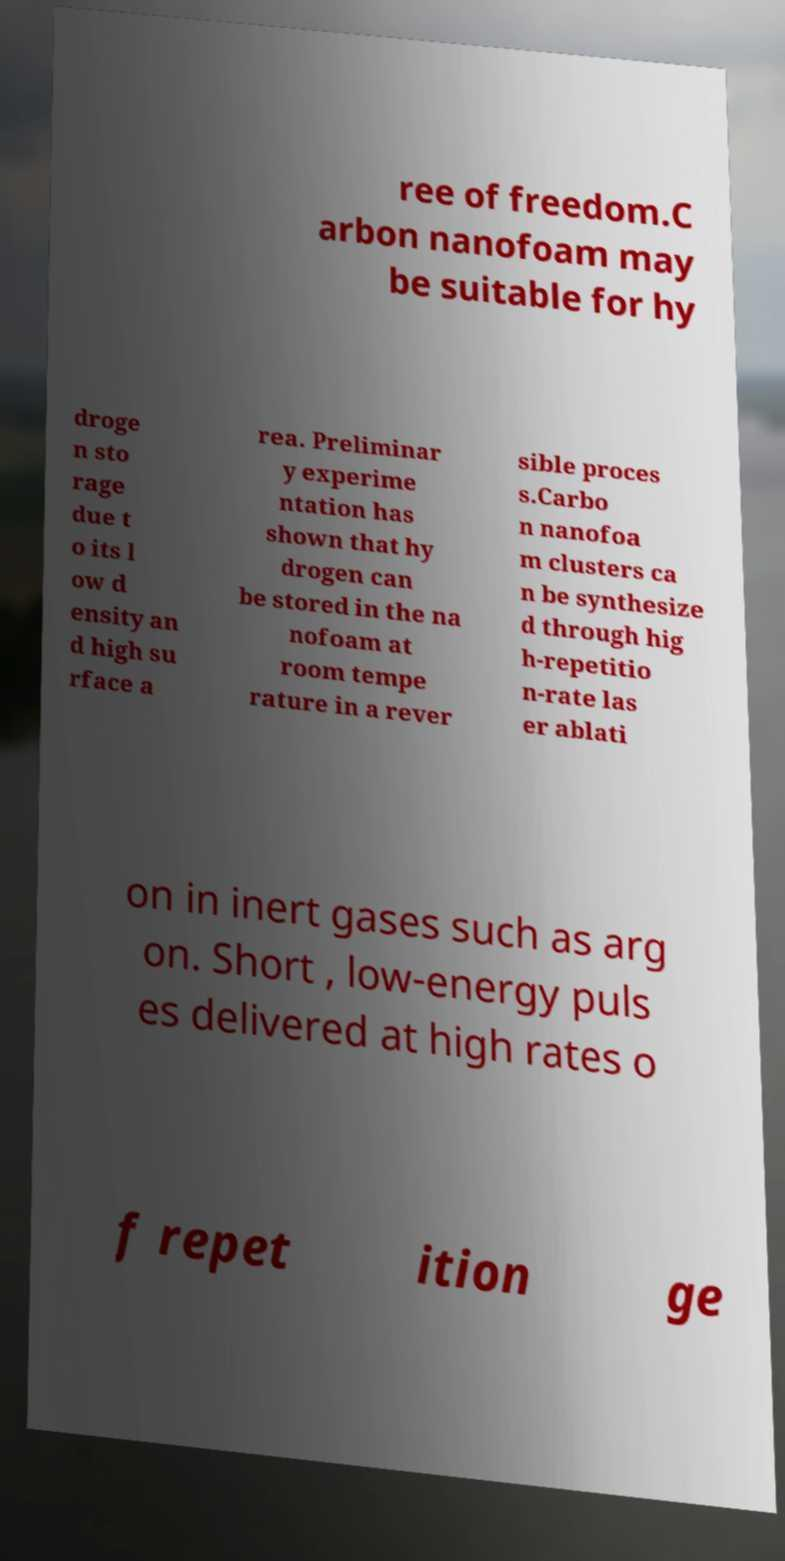Please read and relay the text visible in this image. What does it say? ree of freedom.C arbon nanofoam may be suitable for hy droge n sto rage due t o its l ow d ensity an d high su rface a rea. Preliminar y experime ntation has shown that hy drogen can be stored in the na nofoam at room tempe rature in a rever sible proces s.Carbo n nanofoa m clusters ca n be synthesize d through hig h-repetitio n-rate las er ablati on in inert gases such as arg on. Short , low-energy puls es delivered at high rates o f repet ition ge 